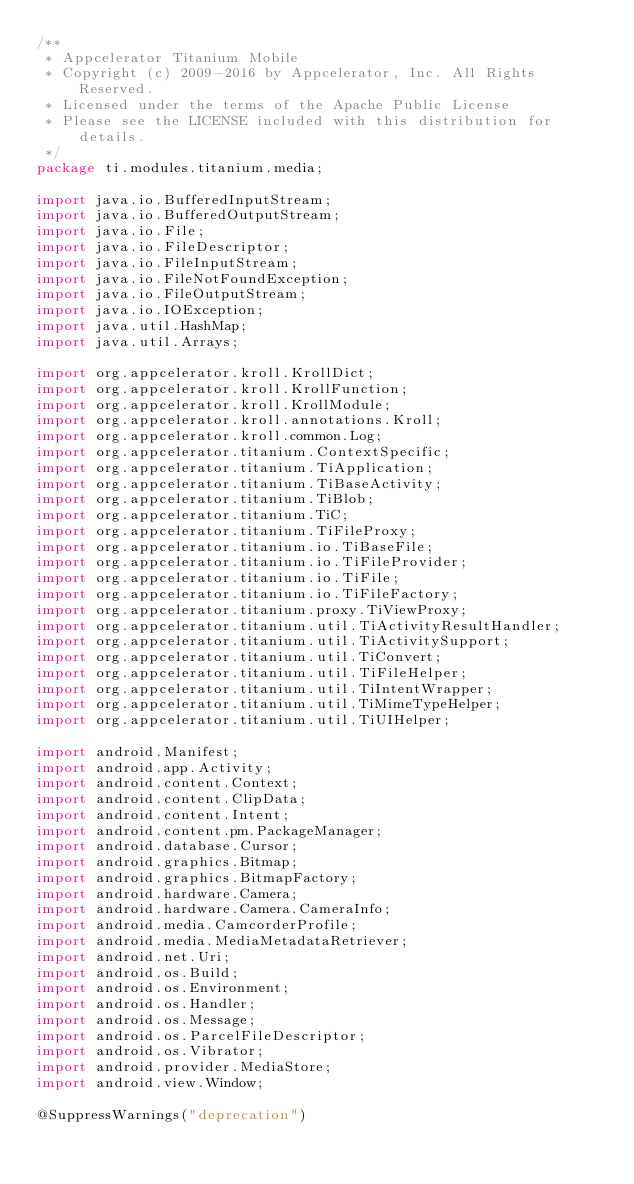<code> <loc_0><loc_0><loc_500><loc_500><_Java_>/**
 * Appcelerator Titanium Mobile
 * Copyright (c) 2009-2016 by Appcelerator, Inc. All Rights Reserved.
 * Licensed under the terms of the Apache Public License
 * Please see the LICENSE included with this distribution for details.
 */
package ti.modules.titanium.media;

import java.io.BufferedInputStream;
import java.io.BufferedOutputStream;
import java.io.File;
import java.io.FileDescriptor;
import java.io.FileInputStream;
import java.io.FileNotFoundException;
import java.io.FileOutputStream;
import java.io.IOException;
import java.util.HashMap;
import java.util.Arrays;

import org.appcelerator.kroll.KrollDict;
import org.appcelerator.kroll.KrollFunction;
import org.appcelerator.kroll.KrollModule;
import org.appcelerator.kroll.annotations.Kroll;
import org.appcelerator.kroll.common.Log;
import org.appcelerator.titanium.ContextSpecific;
import org.appcelerator.titanium.TiApplication;
import org.appcelerator.titanium.TiBaseActivity;
import org.appcelerator.titanium.TiBlob;
import org.appcelerator.titanium.TiC;
import org.appcelerator.titanium.TiFileProxy;
import org.appcelerator.titanium.io.TiBaseFile;
import org.appcelerator.titanium.io.TiFileProvider;
import org.appcelerator.titanium.io.TiFile;
import org.appcelerator.titanium.io.TiFileFactory;
import org.appcelerator.titanium.proxy.TiViewProxy;
import org.appcelerator.titanium.util.TiActivityResultHandler;
import org.appcelerator.titanium.util.TiActivitySupport;
import org.appcelerator.titanium.util.TiConvert;
import org.appcelerator.titanium.util.TiFileHelper;
import org.appcelerator.titanium.util.TiIntentWrapper;
import org.appcelerator.titanium.util.TiMimeTypeHelper;
import org.appcelerator.titanium.util.TiUIHelper;

import android.Manifest;
import android.app.Activity;
import android.content.Context;
import android.content.ClipData;
import android.content.Intent;
import android.content.pm.PackageManager;
import android.database.Cursor;
import android.graphics.Bitmap;
import android.graphics.BitmapFactory;
import android.hardware.Camera;
import android.hardware.Camera.CameraInfo;
import android.media.CamcorderProfile;
import android.media.MediaMetadataRetriever;
import android.net.Uri;
import android.os.Build;
import android.os.Environment;
import android.os.Handler;
import android.os.Message;
import android.os.ParcelFileDescriptor;
import android.os.Vibrator;
import android.provider.MediaStore;
import android.view.Window;

@SuppressWarnings("deprecation")</code> 